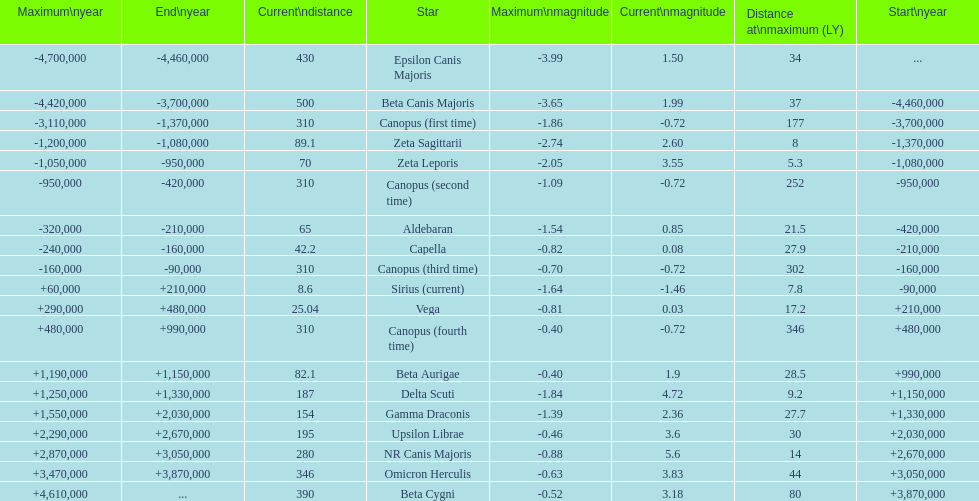Would you be able to parse every entry in this table? {'header': ['Maximum\\nyear', 'End\\nyear', 'Current\\ndistance', 'Star', 'Maximum\\nmagnitude', 'Current\\nmagnitude', 'Distance at\\nmaximum (LY)', 'Start\\nyear'], 'rows': [['-4,700,000', '-4,460,000', '430', 'Epsilon Canis Majoris', '-3.99', '1.50', '34', '...'], ['-4,420,000', '-3,700,000', '500', 'Beta Canis Majoris', '-3.65', '1.99', '37', '-4,460,000'], ['-3,110,000', '-1,370,000', '310', 'Canopus (first time)', '-1.86', '-0.72', '177', '-3,700,000'], ['-1,200,000', '-1,080,000', '89.1', 'Zeta Sagittarii', '-2.74', '2.60', '8', '-1,370,000'], ['-1,050,000', '-950,000', '70', 'Zeta Leporis', '-2.05', '3.55', '5.3', '-1,080,000'], ['-950,000', '-420,000', '310', 'Canopus (second time)', '-1.09', '-0.72', '252', '-950,000'], ['-320,000', '-210,000', '65', 'Aldebaran', '-1.54', '0.85', '21.5', '-420,000'], ['-240,000', '-160,000', '42.2', 'Capella', '-0.82', '0.08', '27.9', '-210,000'], ['-160,000', '-90,000', '310', 'Canopus (third time)', '-0.70', '-0.72', '302', '-160,000'], ['+60,000', '+210,000', '8.6', 'Sirius (current)', '-1.64', '-1.46', '7.8', '-90,000'], ['+290,000', '+480,000', '25.04', 'Vega', '-0.81', '0.03', '17.2', '+210,000'], ['+480,000', '+990,000', '310', 'Canopus (fourth time)', '-0.40', '-0.72', '346', '+480,000'], ['+1,190,000', '+1,150,000', '82.1', 'Beta Aurigae', '-0.40', '1.9', '28.5', '+990,000'], ['+1,250,000', '+1,330,000', '187', 'Delta Scuti', '-1.84', '4.72', '9.2', '+1,150,000'], ['+1,550,000', '+2,030,000', '154', 'Gamma Draconis', '-1.39', '2.36', '27.7', '+1,330,000'], ['+2,290,000', '+2,670,000', '195', 'Upsilon Librae', '-0.46', '3.6', '30', '+2,030,000'], ['+2,870,000', '+3,050,000', '280', 'NR Canis Majoris', '-0.88', '5.6', '14', '+2,670,000'], ['+3,470,000', '+3,870,000', '346', 'Omicron Herculis', '-0.63', '3.83', '44', '+3,050,000'], ['+4,610,000', '...', '390', 'Beta Cygni', '-0.52', '3.18', '80', '+3,870,000']]} How much farther (in ly) is epsilon canis majoris than zeta sagittarii? 26. 